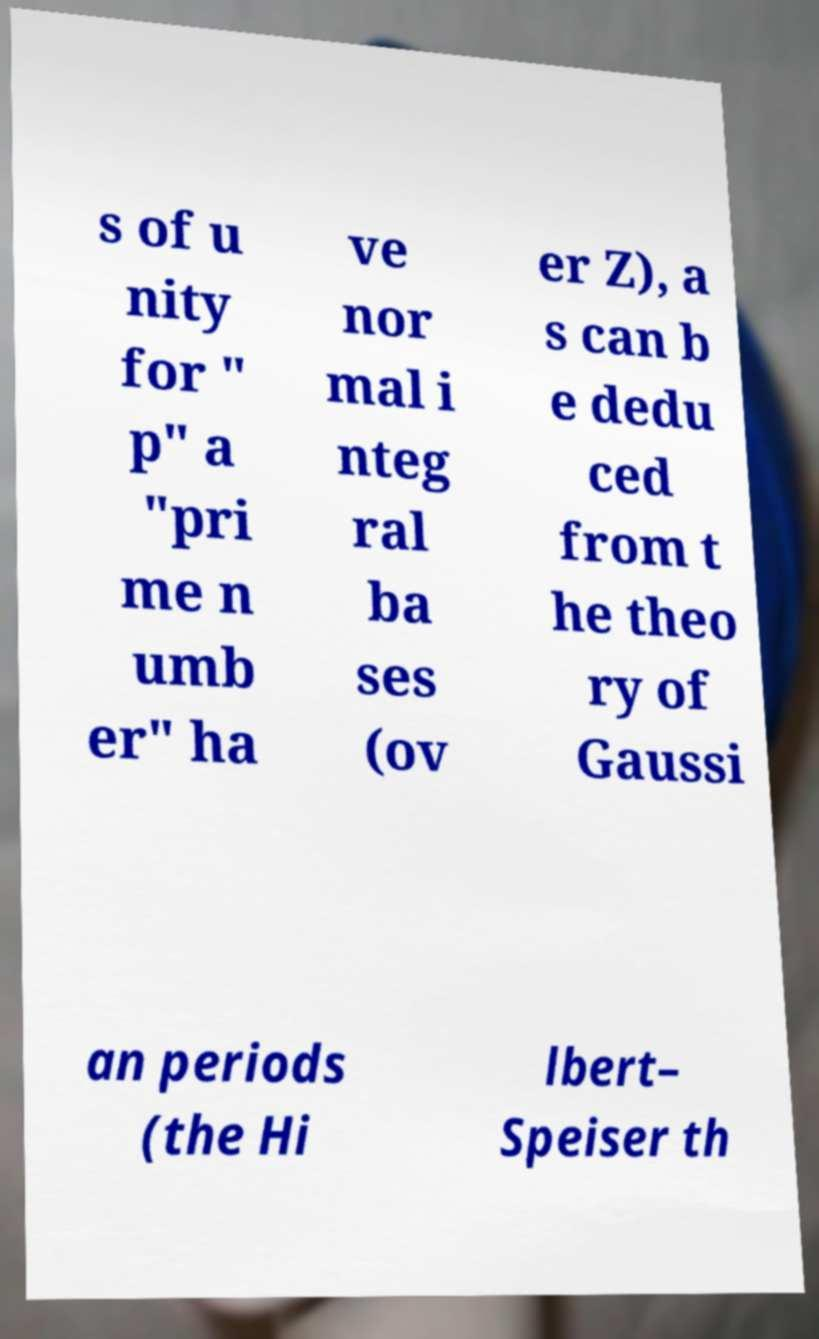Could you extract and type out the text from this image? s of u nity for " p" a "pri me n umb er" ha ve nor mal i nteg ral ba ses (ov er Z), a s can b e dedu ced from t he theo ry of Gaussi an periods (the Hi lbert– Speiser th 